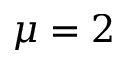Convert formula to latex. <formula><loc_0><loc_0><loc_500><loc_500>\mu = 2</formula> 